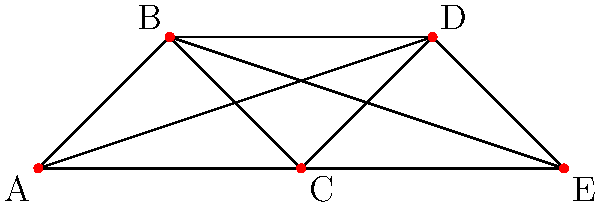In a document management system, different types of documents are represented as vertices in a graph. Two vertices are connected if the corresponding document types cannot be stored in the same category. Given the graph above representing document relationships, what is the minimum number of categories (colors) needed to properly categorize all document types? To solve this graph coloring problem, we'll follow these steps:

1. Analyze the graph structure:
   The graph has 5 vertices (A, B, C, D, E) representing different document types.

2. Identify the maximum degree of the graph:
   Vertex A has 3 edges, B has 3 edges, C has 3 edges, D has 3 edges, and E has 2 edges.
   The maximum degree is 3.

3. Apply Brooks' theorem:
   Brooks' theorem states that for a connected, undirected graph G with maximum degree Δ, the chromatic number χ(G) is at most Δ, unless G is a complete graph or an odd cycle, in which case χ(G) = Δ + 1.

4. Check if the graph is a complete graph or an odd cycle:
   - It's not a complete graph (K5) as not all vertices are connected to each other.
   - It's not an odd cycle as it has 5 vertices but is not a simple cycle.

5. Conclude the chromatic number:
   Since the maximum degree is 3 and the graph is neither a complete graph nor an odd cycle, the chromatic number is at most 3.

6. Verify the coloring:
   We can color the graph with 3 colors:
   A: Color 1
   B: Color 2
   C: Color 2
   D: Color 3
   E: Color 1

Therefore, the minimum number of categories (colors) needed is 3.
Answer: 3 